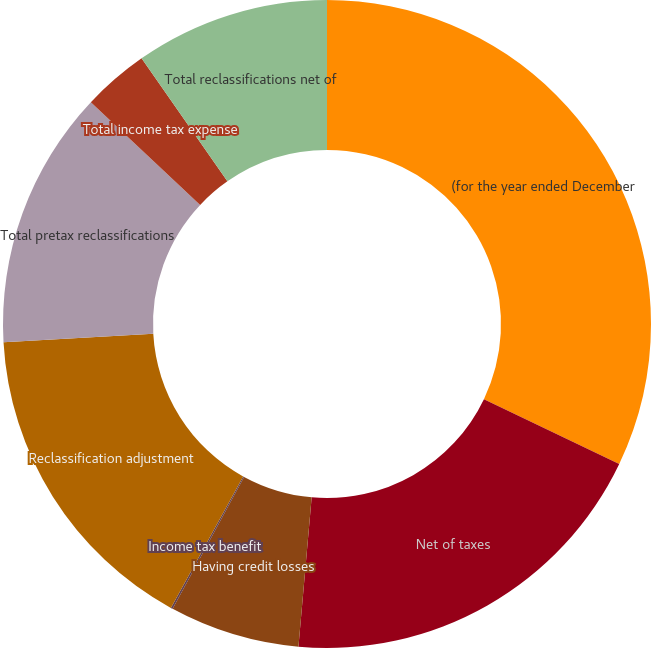Convert chart. <chart><loc_0><loc_0><loc_500><loc_500><pie_chart><fcel>(for the year ended December<fcel>Net of taxes<fcel>Having credit losses<fcel>Income tax benefit<fcel>Reclassification adjustment<fcel>Total pretax reclassifications<fcel>Total income tax expense<fcel>Total reclassifications net of<nl><fcel>32.11%<fcel>19.3%<fcel>6.5%<fcel>0.1%<fcel>16.1%<fcel>12.9%<fcel>3.3%<fcel>9.7%<nl></chart> 